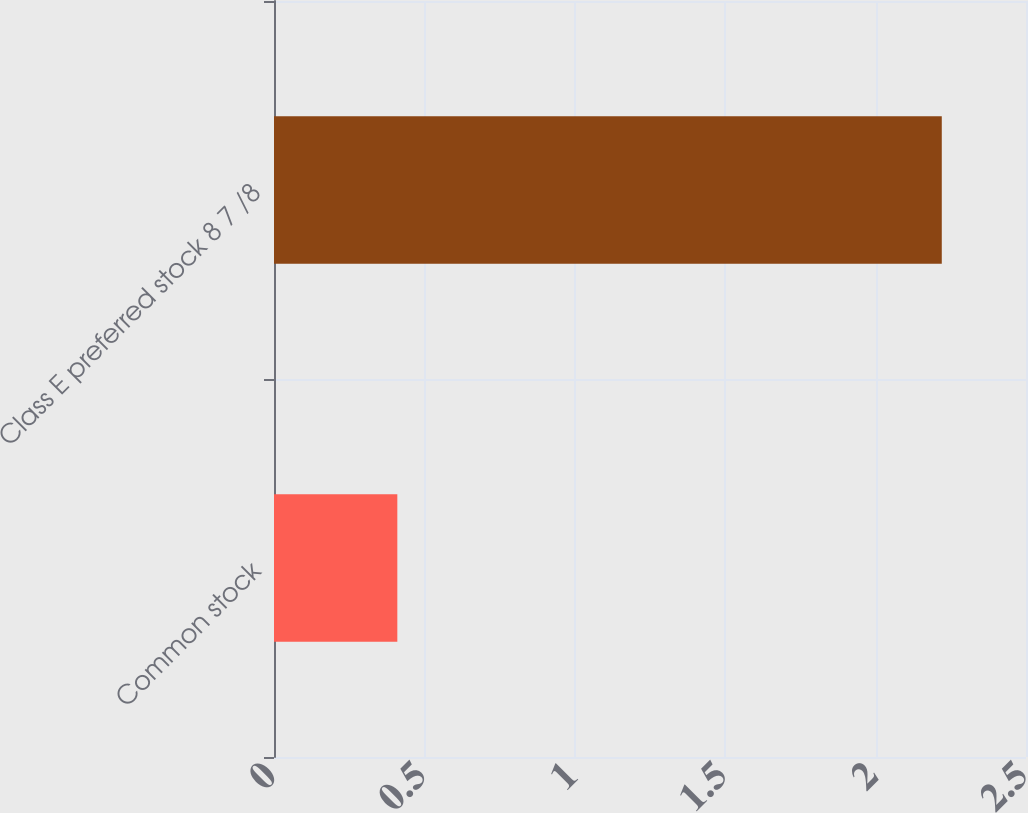<chart> <loc_0><loc_0><loc_500><loc_500><bar_chart><fcel>Common stock<fcel>Class E preferred stock 8 7 /8<nl><fcel>0.41<fcel>2.22<nl></chart> 